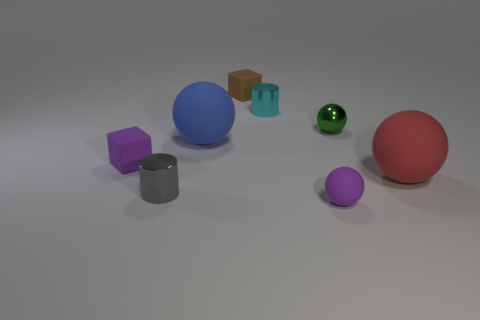What number of objects are tiny purple things left of the tiny brown block or tiny metal cylinders that are left of the blue matte object?
Your answer should be compact. 2. There is a rubber thing that is behind the green shiny sphere; is its color the same as the shiny ball?
Your answer should be very brief. No. What number of other things are there of the same color as the small matte ball?
Provide a short and direct response. 1. What is the gray thing made of?
Provide a succinct answer. Metal. Does the purple object behind the purple rubber ball have the same size as the big red rubber thing?
Provide a short and direct response. No. Is there any other thing that has the same size as the cyan metallic cylinder?
Provide a short and direct response. Yes. There is a purple matte object that is the same shape as the small brown matte object; what size is it?
Offer a very short reply. Small. Is the number of small cyan shiny cylinders that are left of the small gray cylinder the same as the number of metallic cylinders that are behind the brown block?
Offer a terse response. Yes. There is a cube behind the tiny green ball; what size is it?
Ensure brevity in your answer.  Small. Do the tiny rubber sphere and the small metal ball have the same color?
Make the answer very short. No. 